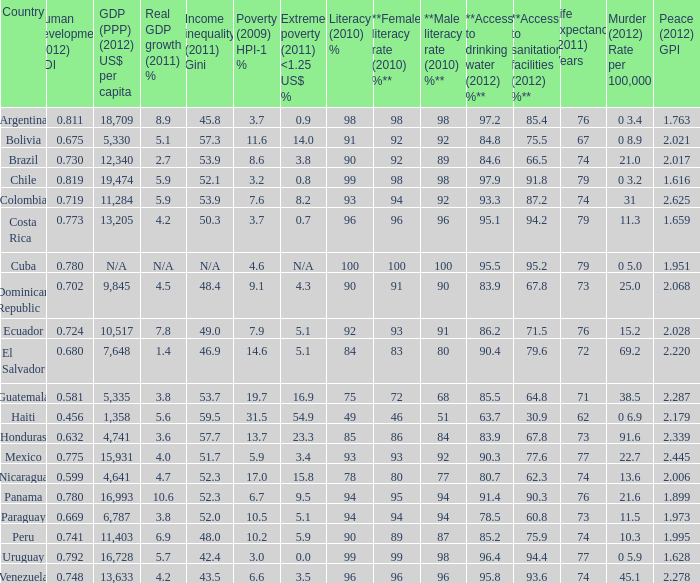What is the total poverty (2009) HPI-1 % when the extreme poverty (2011) <1.25 US$ % of 16.9, and the human development (2012) HDI is less than 0.581? None. 